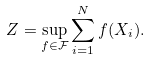<formula> <loc_0><loc_0><loc_500><loc_500>Z = \sup _ { f \in \mathcal { F } } \sum _ { i = 1 } ^ { N } f ( X _ { i } ) .</formula> 